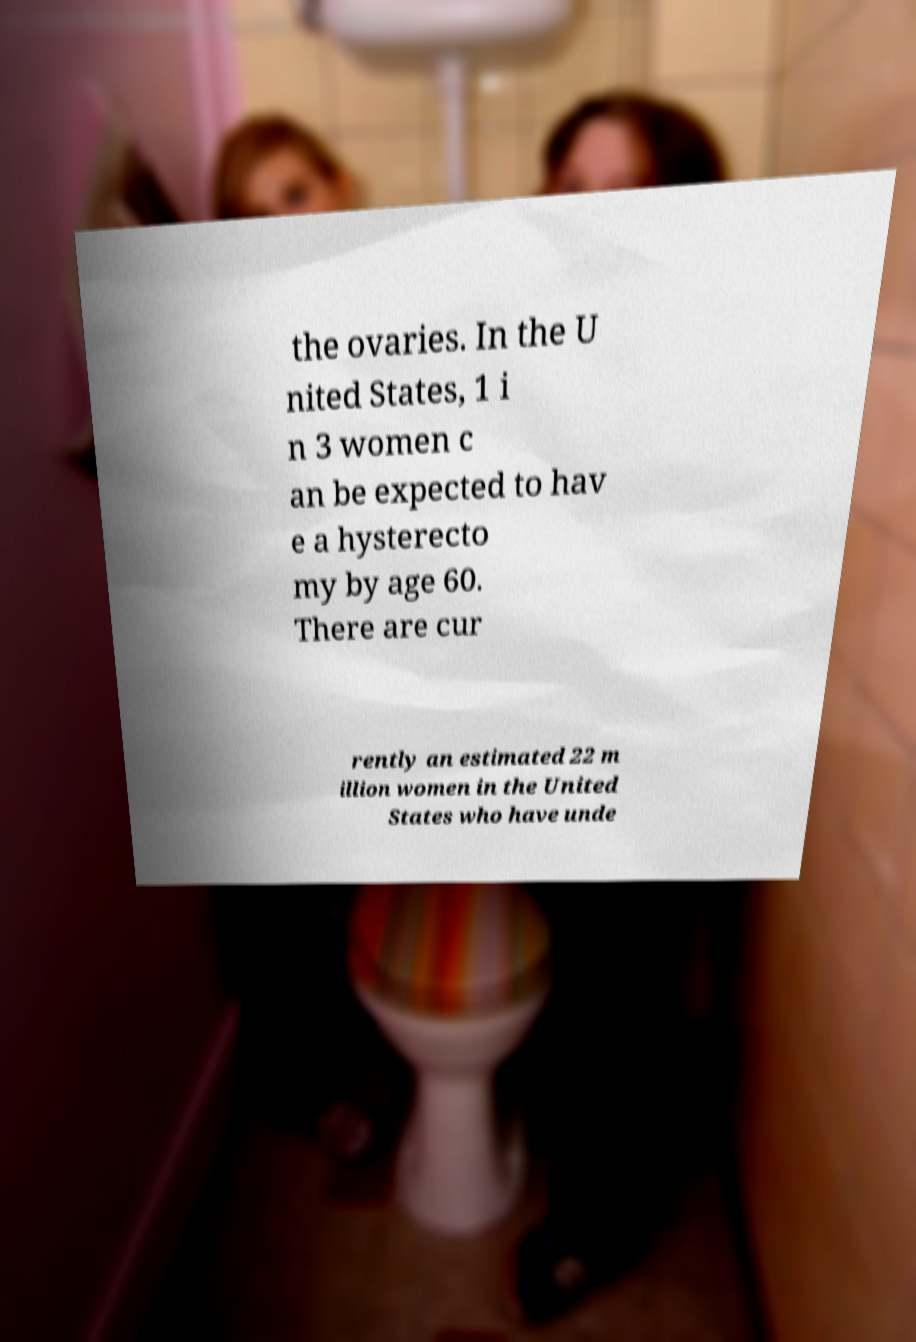Can you read and provide the text displayed in the image?This photo seems to have some interesting text. Can you extract and type it out for me? the ovaries. In the U nited States, 1 i n 3 women c an be expected to hav e a hysterecto my by age 60. There are cur rently an estimated 22 m illion women in the United States who have unde 